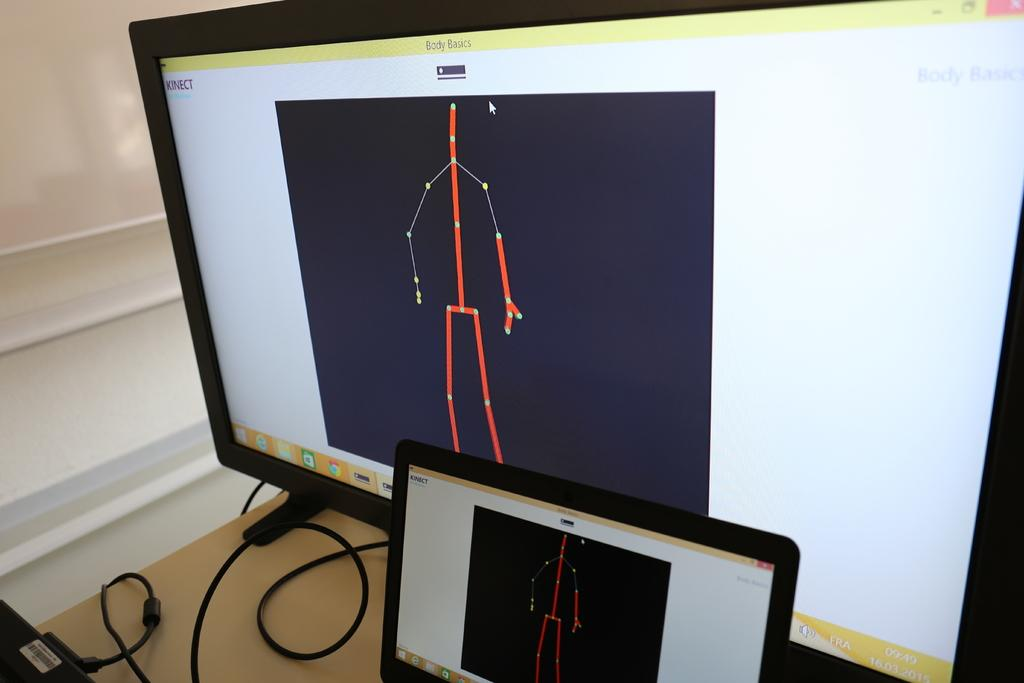<image>
Share a concise interpretation of the image provided. A computer monitor with a phone in front both with a stick figure in red with dots on the body.. 